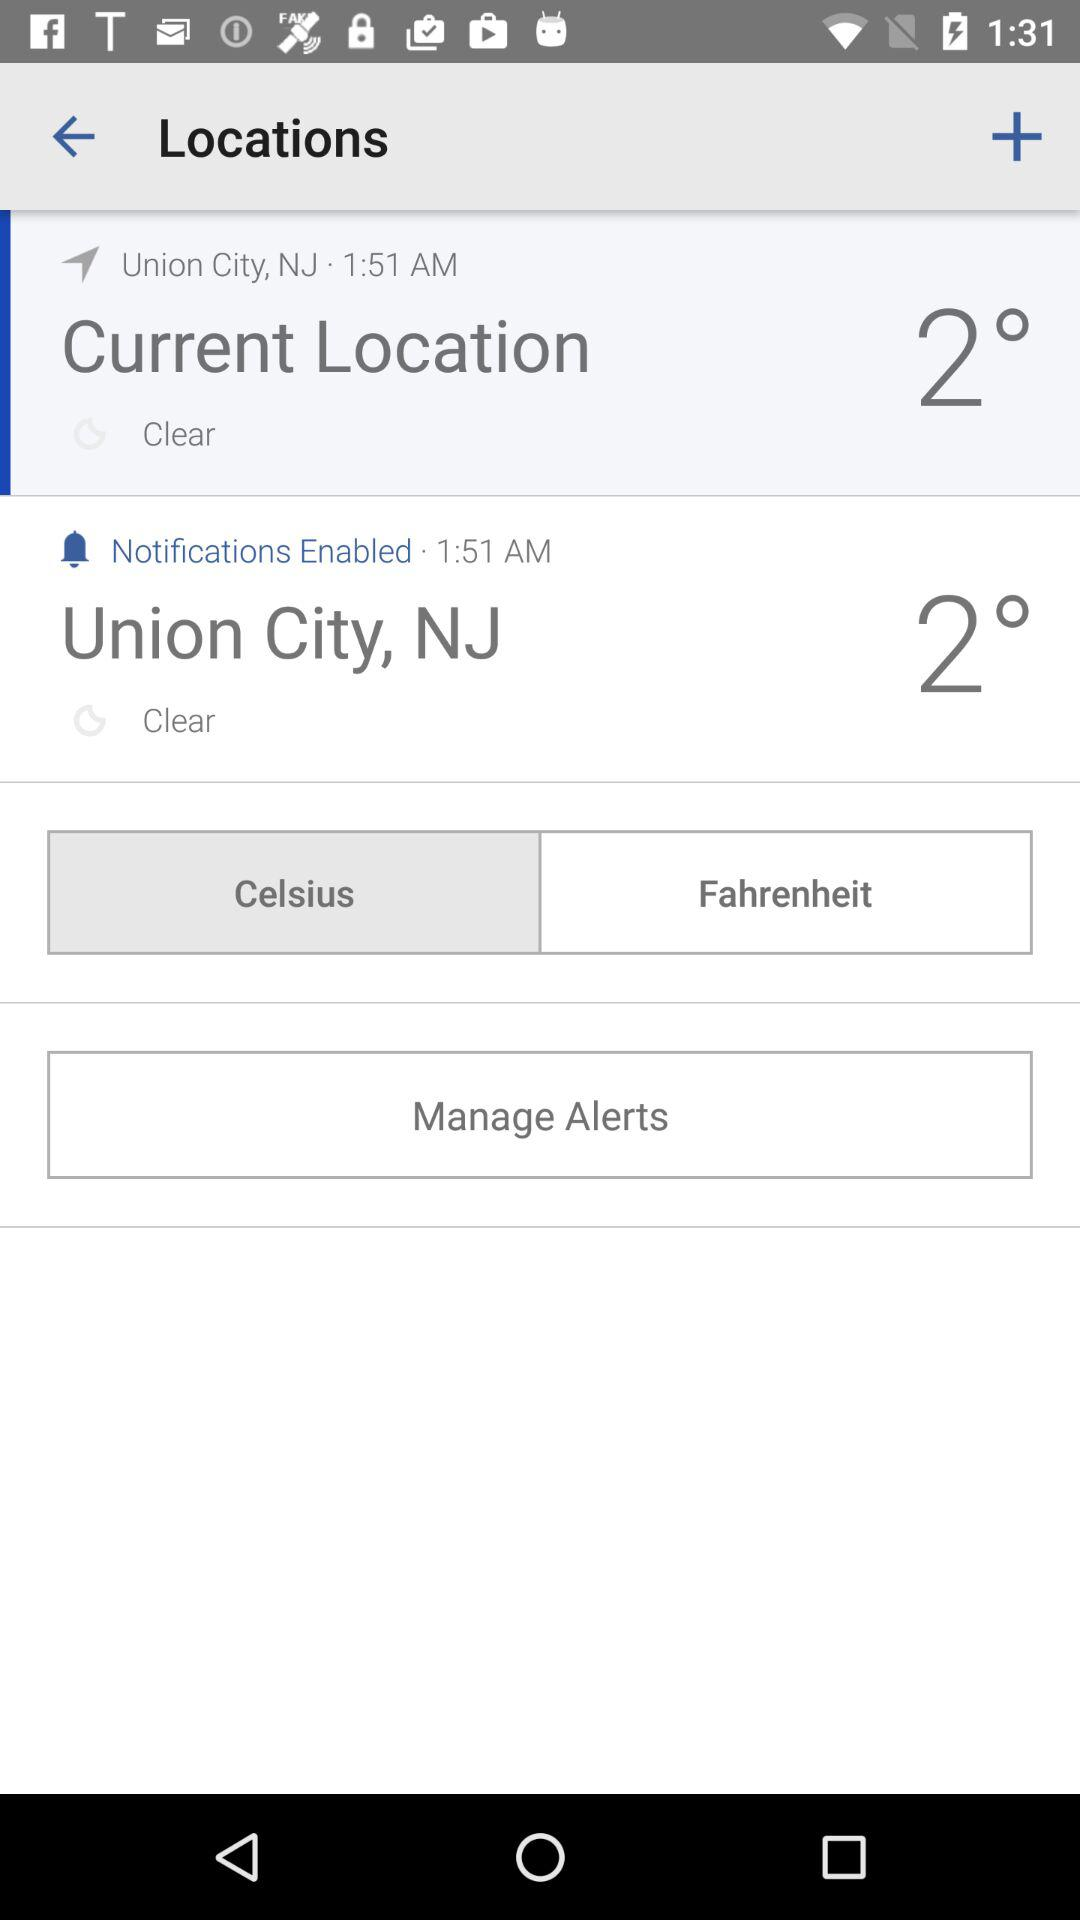What is the current location? The current location is Union City, NJ. 